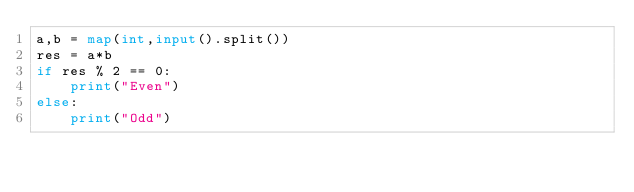Convert code to text. <code><loc_0><loc_0><loc_500><loc_500><_Python_>a,b = map(int,input().split())
res = a*b
if res % 2 == 0:
    print("Even")
else:
    print("Odd")
</code> 